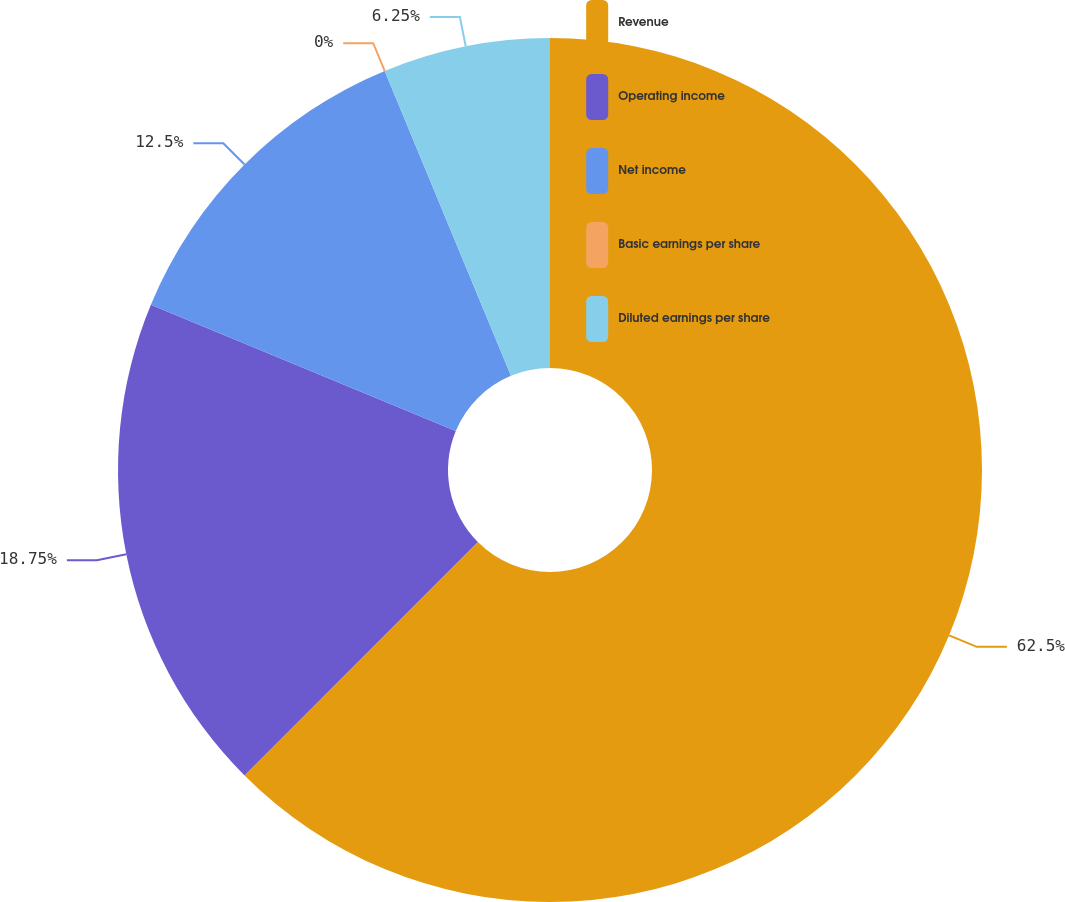Convert chart. <chart><loc_0><loc_0><loc_500><loc_500><pie_chart><fcel>Revenue<fcel>Operating income<fcel>Net income<fcel>Basic earnings per share<fcel>Diluted earnings per share<nl><fcel>62.5%<fcel>18.75%<fcel>12.5%<fcel>0.0%<fcel>6.25%<nl></chart> 